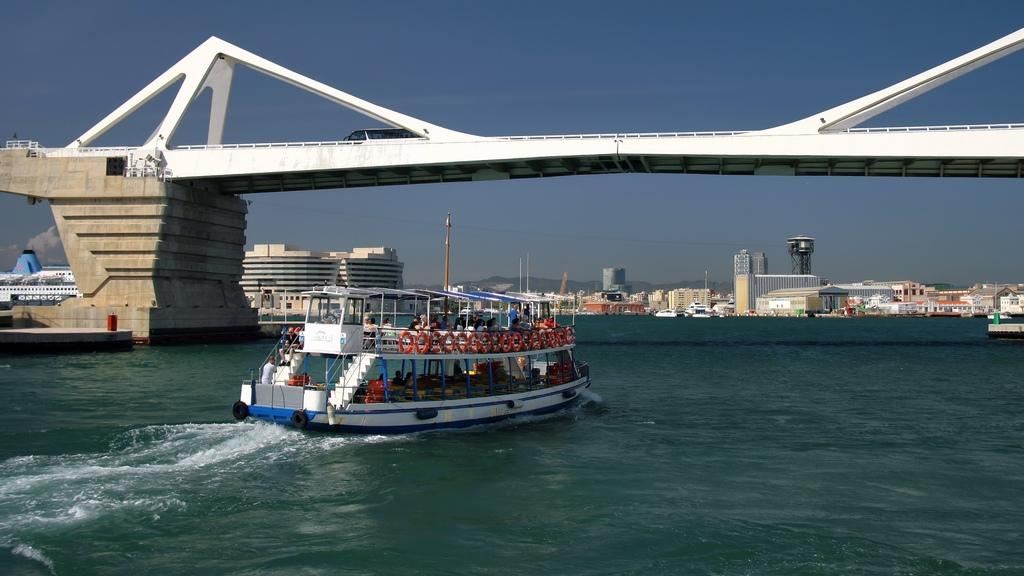What is the main subject of the image? The main subject of the image is a ship. Where is the ship located? The ship is on the water. What can be seen behind the ship? There is a bridge and buildings behind the ship. Can you describe any other objects in the image? There is a pole visible in the image. What is visible in the background of the image? The sky is visible in the background. What type of cap is the society wearing in the image? There is no society or cap present in the image; it features a ship on the water with a bridge and buildings in the background. 